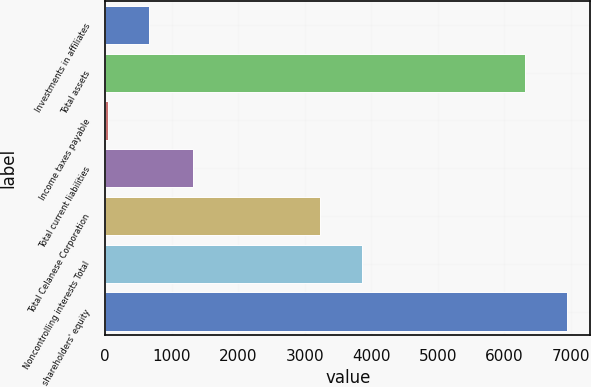Convert chart. <chart><loc_0><loc_0><loc_500><loc_500><bar_chart><fcel>Investments in affiliates<fcel>Total assets<fcel>Income taxes payable<fcel>Total current liabilities<fcel>Total Celanese Corporation<fcel>Noncontrolling interests Total<fcel>shareholders' equity<nl><fcel>666.8<fcel>6317<fcel>39<fcel>1316<fcel>3231<fcel>3858.8<fcel>6944.8<nl></chart> 